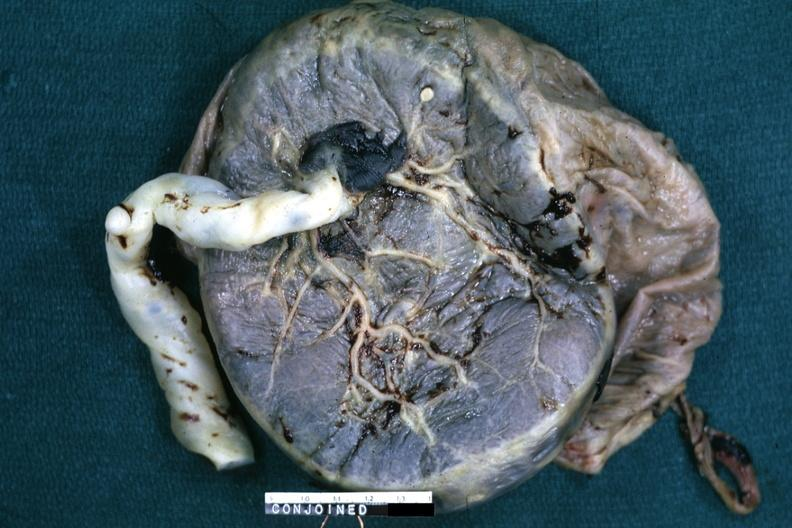does interesting case show fixed tissue single placenta with very large cord?
Answer the question using a single word or phrase. No 